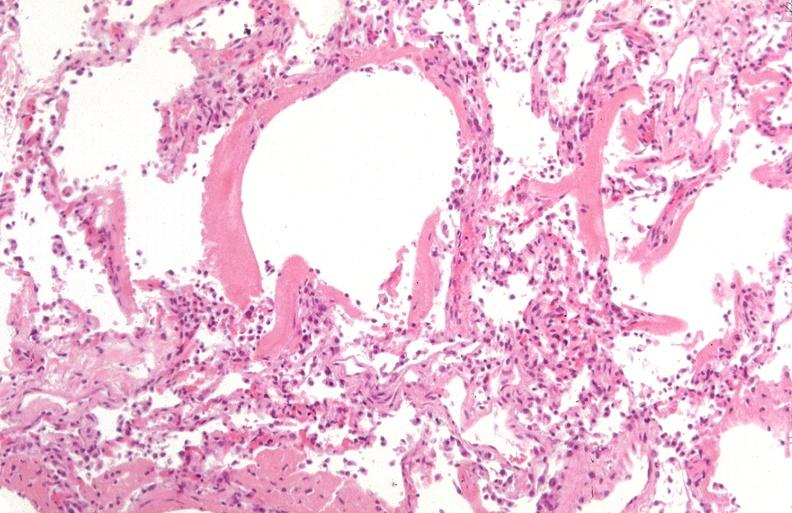what is present?
Answer the question using a single word or phrase. Respiratory 